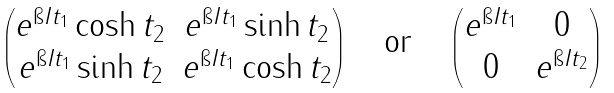<formula> <loc_0><loc_0><loc_500><loc_500>\begin{pmatrix} e ^ { \i I t _ { 1 } } \cosh t _ { 2 } & e ^ { \i I t _ { 1 } } \sinh t _ { 2 } \\ e ^ { \i I t _ { 1 } } \sinh t _ { 2 } & e ^ { \i I t _ { 1 } } \cosh t _ { 2 } \end{pmatrix} \quad \text {or} \quad \begin{pmatrix} e ^ { \i I t _ { 1 } } & 0 \\ 0 & e ^ { \i I t _ { 2 } } \end{pmatrix}</formula> 